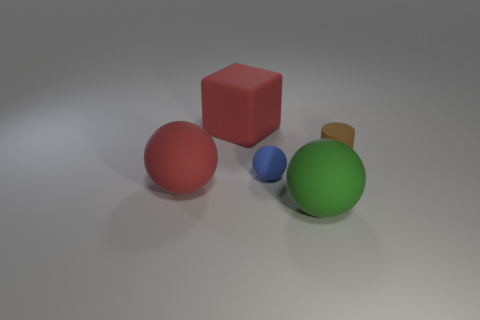Add 2 tiny blue rubber objects. How many objects exist? 7 Subtract all balls. How many objects are left? 2 Add 3 big green matte spheres. How many big green matte spheres exist? 4 Subtract 0 blue cubes. How many objects are left? 5 Subtract all small matte balls. Subtract all brown cylinders. How many objects are left? 3 Add 5 tiny brown objects. How many tiny brown objects are left? 6 